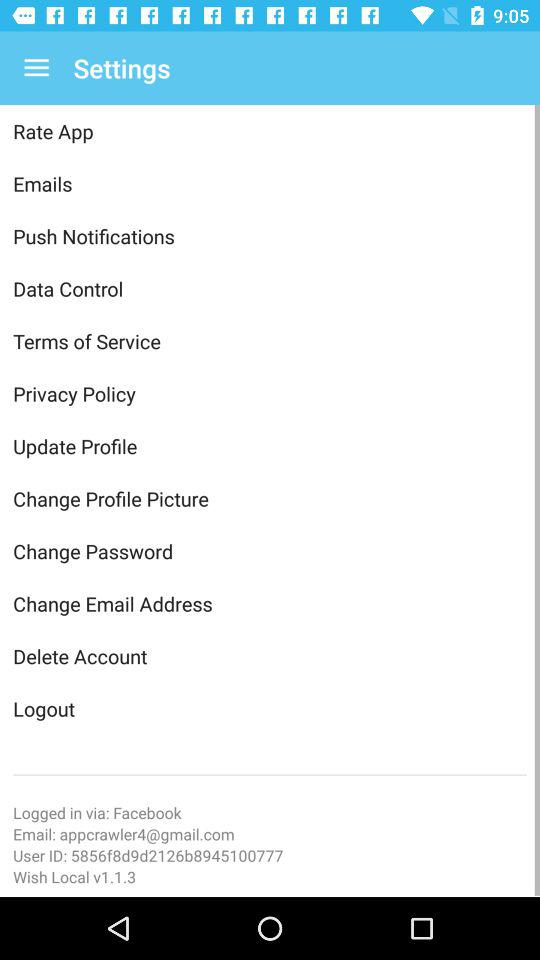What version is used? The version is 1.1.3. 